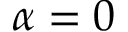Convert formula to latex. <formula><loc_0><loc_0><loc_500><loc_500>\alpha = 0</formula> 